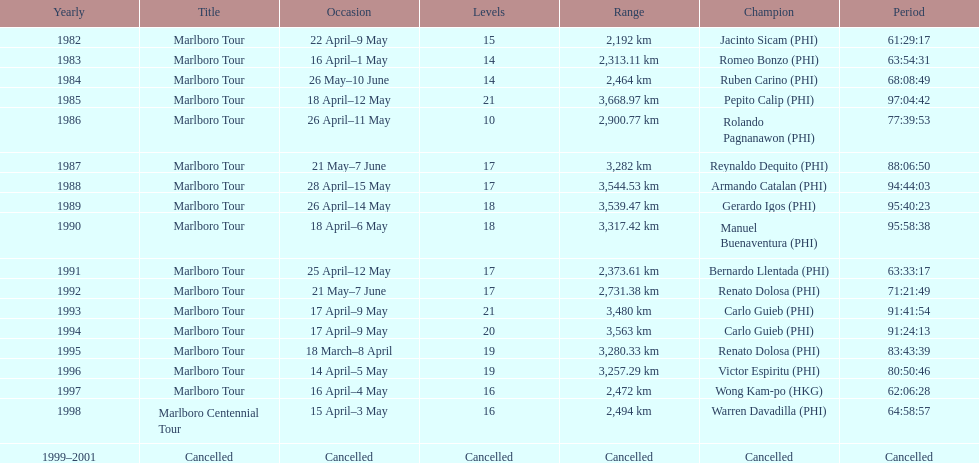What was the largest distance traveled for the marlboro tour? 3,668.97 km. 